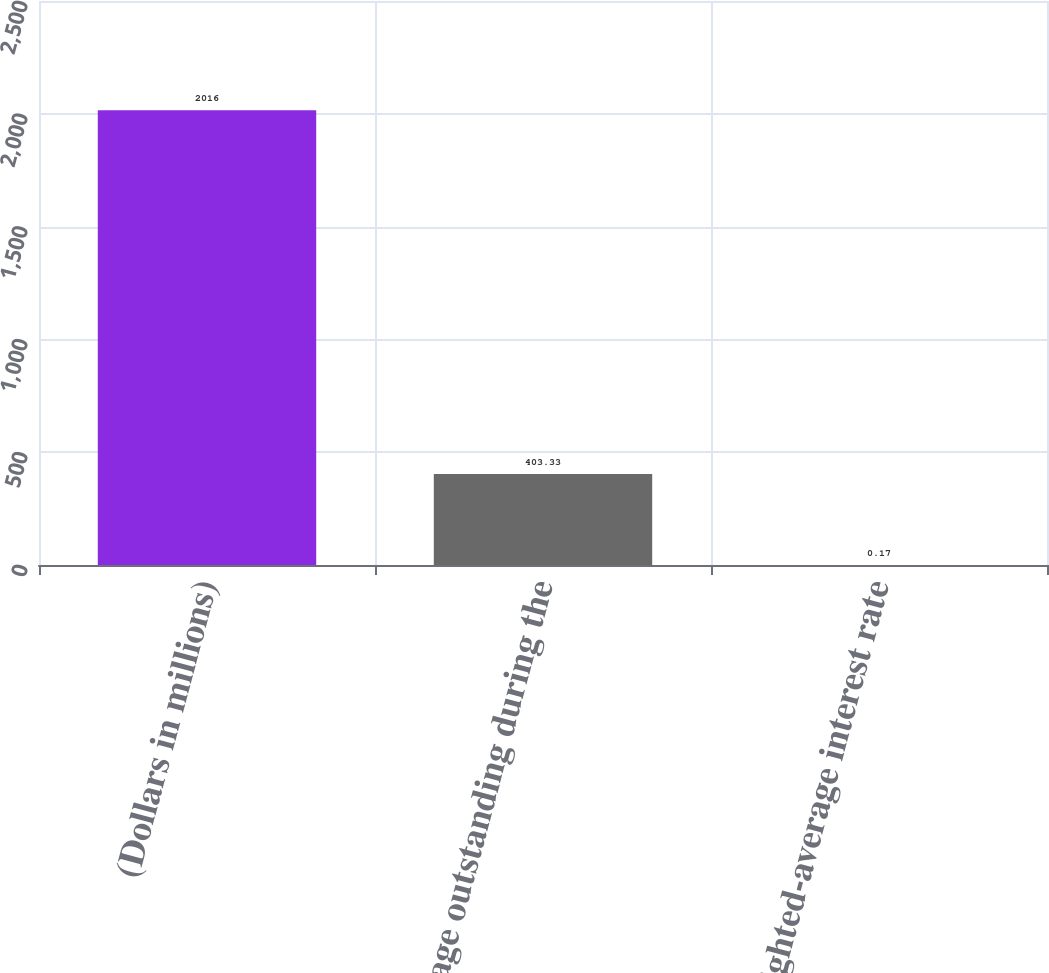<chart> <loc_0><loc_0><loc_500><loc_500><bar_chart><fcel>(Dollars in millions)<fcel>Average outstanding during the<fcel>Weighted-average interest rate<nl><fcel>2016<fcel>403.33<fcel>0.17<nl></chart> 